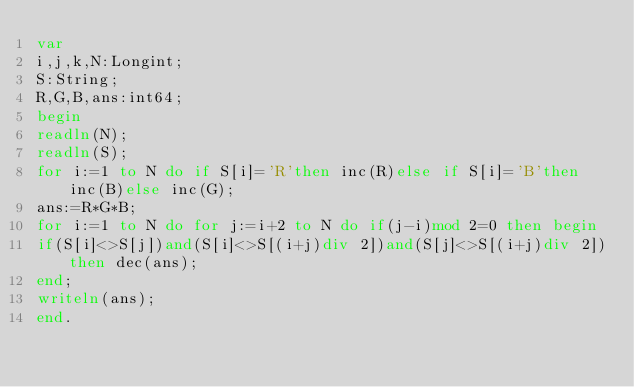Convert code to text. <code><loc_0><loc_0><loc_500><loc_500><_Pascal_>var
i,j,k,N:Longint;
S:String;
R,G,B,ans:int64;
begin
readln(N);
readln(S);
for i:=1 to N do if S[i]='R'then inc(R)else if S[i]='B'then inc(B)else inc(G);
ans:=R*G*B;
for i:=1 to N do for j:=i+2 to N do if(j-i)mod 2=0 then begin
if(S[i]<>S[j])and(S[i]<>S[(i+j)div 2])and(S[j]<>S[(i+j)div 2])then dec(ans);
end;
writeln(ans);
end.</code> 